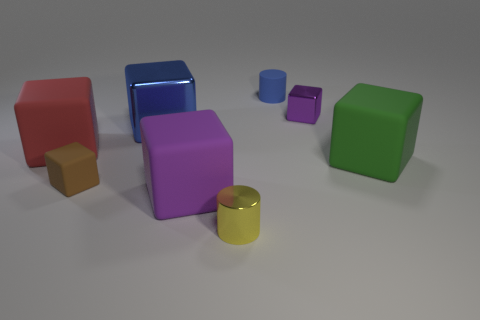Does the blue metal cube have the same size as the blue rubber thing?
Make the answer very short. No. Are there any large green cubes that are in front of the big block on the right side of the purple thing that is behind the red matte cube?
Make the answer very short. No. There is a blue thing that is the same shape as the brown thing; what is it made of?
Your answer should be very brief. Metal. How many tiny cylinders are on the left side of the rubber thing behind the red matte cube?
Offer a very short reply. 1. How big is the cylinder that is on the left side of the tiny blue rubber cylinder behind the red matte cube left of the purple matte block?
Offer a very short reply. Small. What color is the large matte thing that is right of the metal thing that is in front of the big green rubber block?
Keep it short and to the point. Green. How many other things are there of the same material as the green block?
Keep it short and to the point. 4. What number of other things are the same color as the metallic cylinder?
Your answer should be compact. 0. The small cylinder behind the metallic cube to the right of the purple matte cube is made of what material?
Ensure brevity in your answer.  Rubber. Are there any brown things?
Offer a very short reply. Yes. 